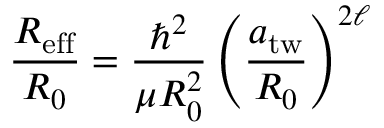Convert formula to latex. <formula><loc_0><loc_0><loc_500><loc_500>\begin{array} { r l r } { { \frac { R _ { e f f } } { R _ { 0 } } = \frac { \hbar { ^ } { 2 } } { \mu R _ { 0 } ^ { 2 } } \left ( \frac { a _ { t w } } { R _ { 0 } } \right ) ^ { 2 \ell } } } \end{array}</formula> 